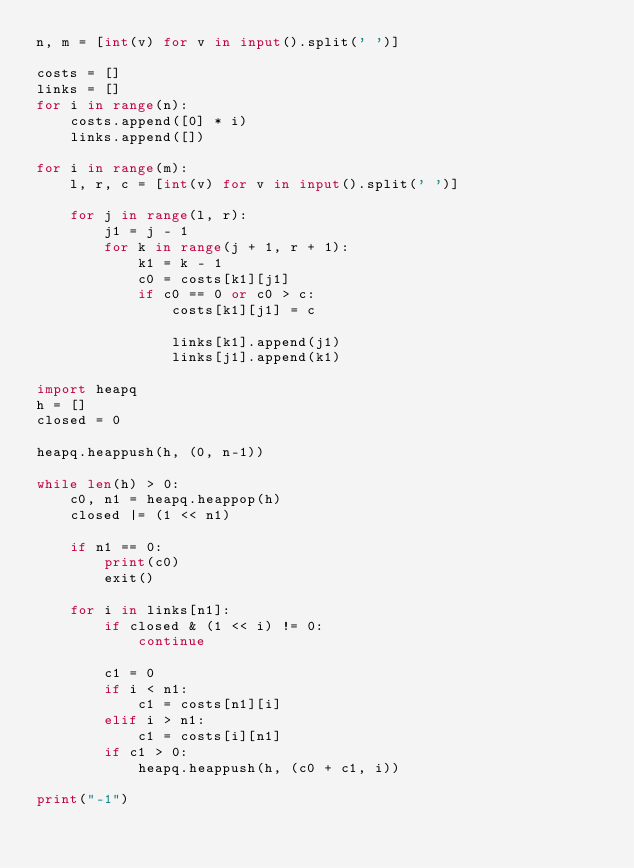Convert code to text. <code><loc_0><loc_0><loc_500><loc_500><_Python_>n, m = [int(v) for v in input().split(' ')]

costs = []
links = []
for i in range(n):
    costs.append([0] * i)
    links.append([])

for i in range(m):
    l, r, c = [int(v) for v in input().split(' ')]

    for j in range(l, r):
        j1 = j - 1
        for k in range(j + 1, r + 1):
            k1 = k - 1
            c0 = costs[k1][j1]
            if c0 == 0 or c0 > c:
                costs[k1][j1] = c

                links[k1].append(j1)
                links[j1].append(k1)

import heapq
h = []
closed = 0

heapq.heappush(h, (0, n-1))

while len(h) > 0:
    c0, n1 = heapq.heappop(h)
    closed |= (1 << n1)

    if n1 == 0:
        print(c0)
        exit()

    for i in links[n1]:
        if closed & (1 << i) != 0:
            continue

        c1 = 0
        if i < n1:
            c1 = costs[n1][i]
        elif i > n1:
            c1 = costs[i][n1]
        if c1 > 0:
            heapq.heappush(h, (c0 + c1, i))

print("-1")</code> 